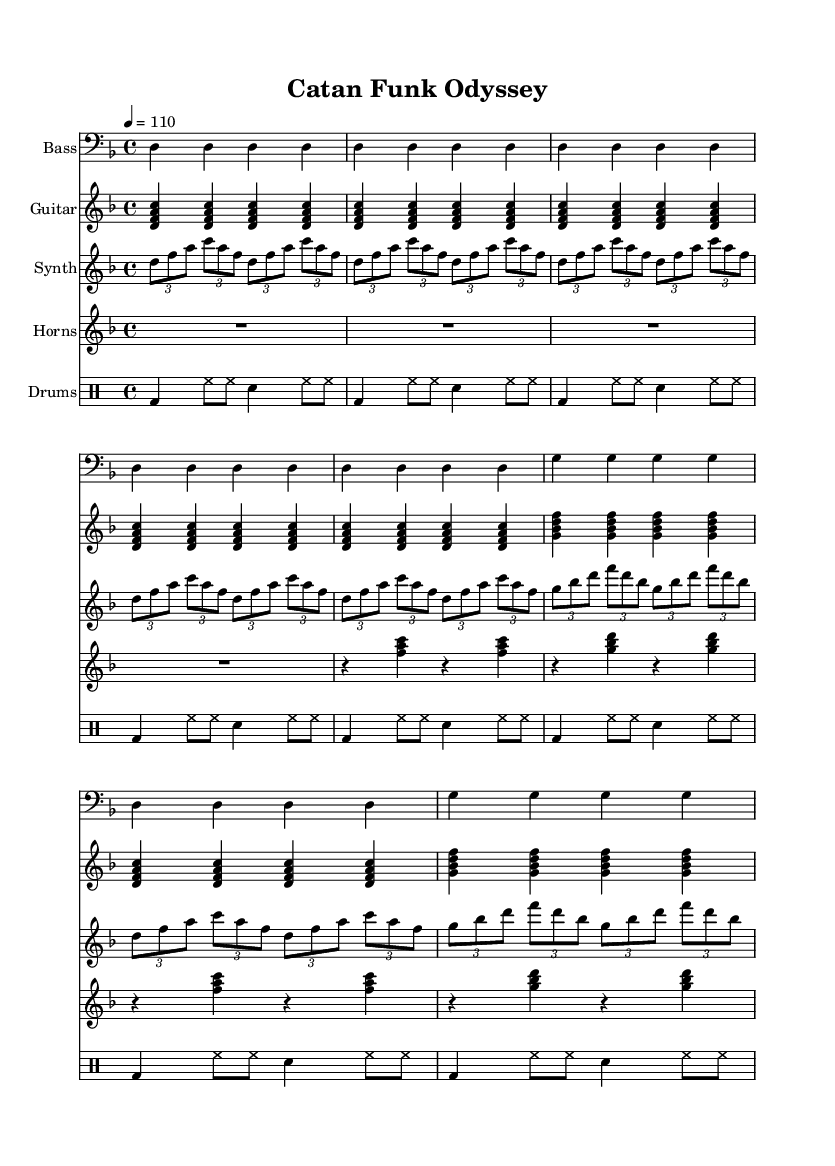What is the key signature of this music? The key signature is indicated by the sharps or flats at the beginning of the staff. In this case, it shows two flats, which correspond to D minor.
Answer: D minor What is the time signature of this sheet music? The time signature is found at the beginning and indicates how many beats are in a measure. Here, it shows 4/4, meaning there are four beats per measure.
Answer: 4/4 What is the tempo marking of this piece? The tempo marking is given in beats per minute at the start of the score. It states "4 = 110," meaning there are 110 beats per minute.
Answer: 110 How many measures does the bass line repeat before changing? By counting the repeated sections in the bass line, we see that it repeats for a total of 6 measures before a change occurs. The pattern clearly shows 4 measures initially and 2 measures of a different section.
Answer: 6 What instrument has the highest range in the score? We assess each instrument's clefs and their relative pitch. The synth and guitar parts are compared, and since the guitar is written in treble clef and plays higher notes, it is determined that the electric guitar has the highest range.
Answer: Guitar What kind of rhythm do the drum patterns follow? The drum patterns indicate a combination of whole, half, and eighth notes, with a regular kick and snare rhythm. This signature pattern reflects a funk style, characterized by syncopated and repeated rhythms.
Answer: Funk pattern What type of musical sections are featured in the synth arpeggio? Analyzing the synth arpeggio, it utilizes tuplets (specifically triplets), creating a distinct rhythmic feel typical in funk music, which balances between rhythmically driven melody and harmony.
Answer: Triplet sections 